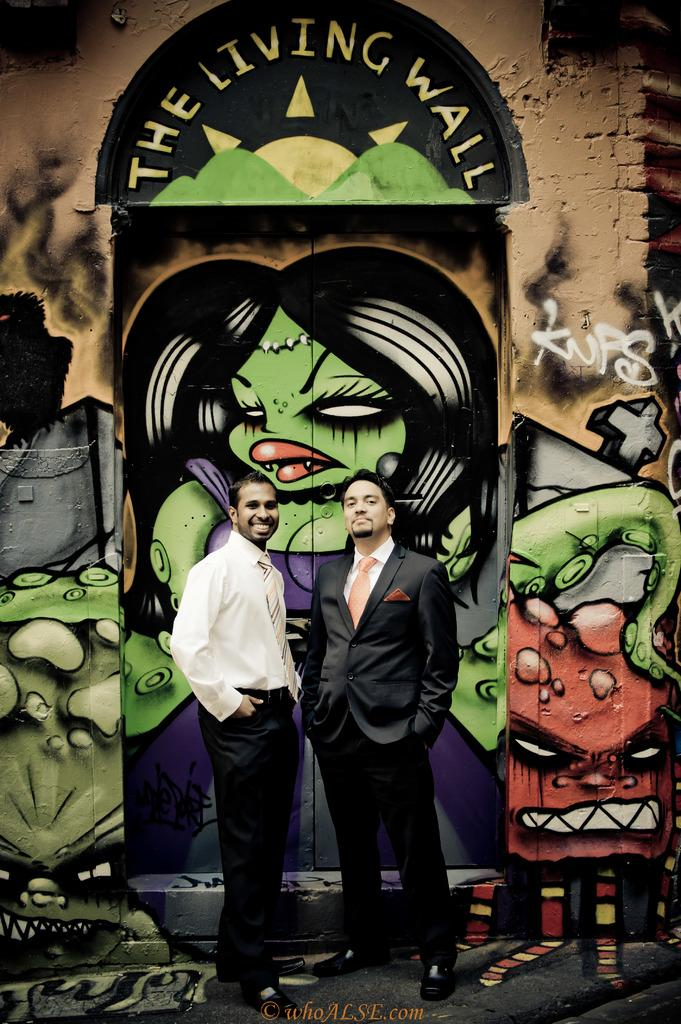How many people are in the image? There are two men standing in the image. Where are the men located in the image? The men are standing on the floor. What can be seen in the background of the image? There is a wall and a door in the background of the image. What is present on the wall and door? Drawings are visible on the wall and door. What type of apple is being suggested for development in the image? There is no apple or suggestion for development present in the image. 